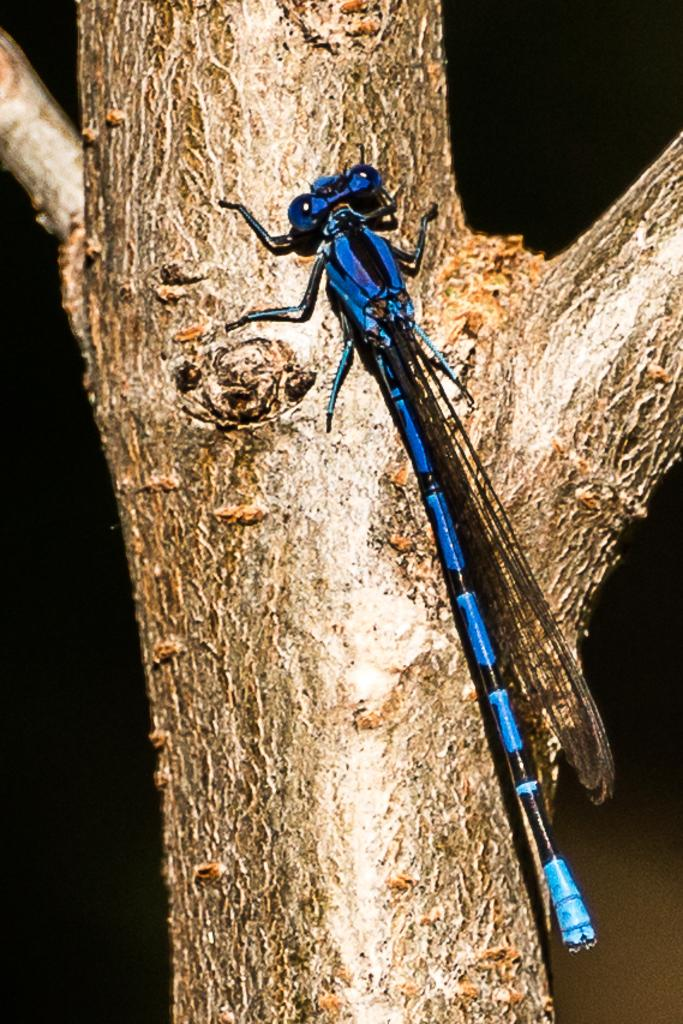What type of insect is present in the image? There is a blue fly in the image. Where is the fly located on the tree? The fly is sitting on the bark of a tree. What type of basin is visible in the image? There is no basin present in the image; it only features a blue fly sitting on the bark of a tree. 